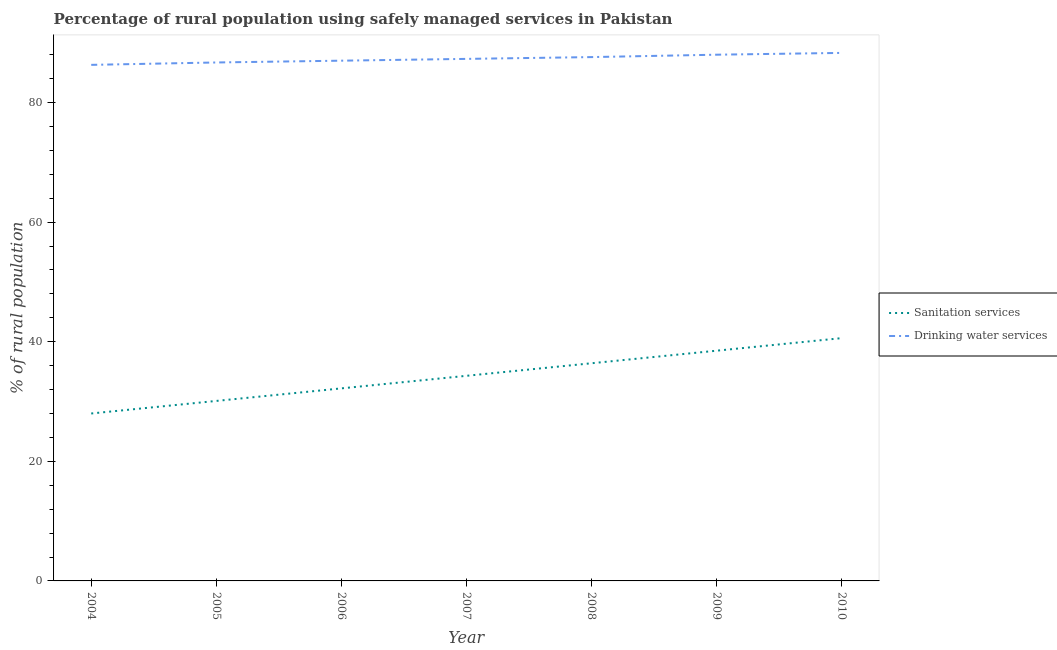Does the line corresponding to percentage of rural population who used sanitation services intersect with the line corresponding to percentage of rural population who used drinking water services?
Keep it short and to the point. No. Is the number of lines equal to the number of legend labels?
Offer a terse response. Yes. What is the percentage of rural population who used sanitation services in 2007?
Provide a succinct answer. 34.3. Across all years, what is the maximum percentage of rural population who used drinking water services?
Offer a terse response. 88.3. Across all years, what is the minimum percentage of rural population who used sanitation services?
Your answer should be compact. 28. In which year was the percentage of rural population who used sanitation services minimum?
Offer a terse response. 2004. What is the total percentage of rural population who used drinking water services in the graph?
Make the answer very short. 611.2. What is the difference between the percentage of rural population who used sanitation services in 2004 and that in 2007?
Provide a short and direct response. -6.3. What is the difference between the percentage of rural population who used drinking water services in 2010 and the percentage of rural population who used sanitation services in 2009?
Offer a very short reply. 49.8. What is the average percentage of rural population who used drinking water services per year?
Ensure brevity in your answer.  87.31. In the year 2009, what is the difference between the percentage of rural population who used sanitation services and percentage of rural population who used drinking water services?
Your answer should be very brief. -49.5. What is the ratio of the percentage of rural population who used drinking water services in 2005 to that in 2009?
Offer a terse response. 0.99. Is the percentage of rural population who used sanitation services in 2006 less than that in 2009?
Make the answer very short. Yes. Is the difference between the percentage of rural population who used drinking water services in 2007 and 2008 greater than the difference between the percentage of rural population who used sanitation services in 2007 and 2008?
Offer a very short reply. Yes. What is the difference between the highest and the second highest percentage of rural population who used sanitation services?
Give a very brief answer. 2.1. What is the difference between the highest and the lowest percentage of rural population who used drinking water services?
Give a very brief answer. 2. In how many years, is the percentage of rural population who used drinking water services greater than the average percentage of rural population who used drinking water services taken over all years?
Ensure brevity in your answer.  3. Is the sum of the percentage of rural population who used sanitation services in 2005 and 2010 greater than the maximum percentage of rural population who used drinking water services across all years?
Ensure brevity in your answer.  No. Does the percentage of rural population who used sanitation services monotonically increase over the years?
Give a very brief answer. Yes. Is the percentage of rural population who used drinking water services strictly greater than the percentage of rural population who used sanitation services over the years?
Your answer should be compact. Yes. How many lines are there?
Your answer should be very brief. 2. How many years are there in the graph?
Your answer should be very brief. 7. Are the values on the major ticks of Y-axis written in scientific E-notation?
Your response must be concise. No. Does the graph contain any zero values?
Provide a succinct answer. No. How many legend labels are there?
Provide a succinct answer. 2. What is the title of the graph?
Provide a short and direct response. Percentage of rural population using safely managed services in Pakistan. Does "DAC donors" appear as one of the legend labels in the graph?
Keep it short and to the point. No. What is the label or title of the X-axis?
Provide a short and direct response. Year. What is the label or title of the Y-axis?
Your answer should be compact. % of rural population. What is the % of rural population in Sanitation services in 2004?
Offer a terse response. 28. What is the % of rural population of Drinking water services in 2004?
Offer a very short reply. 86.3. What is the % of rural population of Sanitation services in 2005?
Your answer should be very brief. 30.1. What is the % of rural population in Drinking water services in 2005?
Give a very brief answer. 86.7. What is the % of rural population of Sanitation services in 2006?
Your response must be concise. 32.2. What is the % of rural population of Sanitation services in 2007?
Your response must be concise. 34.3. What is the % of rural population in Drinking water services in 2007?
Ensure brevity in your answer.  87.3. What is the % of rural population of Sanitation services in 2008?
Your answer should be compact. 36.4. What is the % of rural population in Drinking water services in 2008?
Your response must be concise. 87.6. What is the % of rural population in Sanitation services in 2009?
Make the answer very short. 38.5. What is the % of rural population of Drinking water services in 2009?
Your answer should be very brief. 88. What is the % of rural population of Sanitation services in 2010?
Ensure brevity in your answer.  40.6. What is the % of rural population in Drinking water services in 2010?
Ensure brevity in your answer.  88.3. Across all years, what is the maximum % of rural population in Sanitation services?
Make the answer very short. 40.6. Across all years, what is the maximum % of rural population of Drinking water services?
Your answer should be compact. 88.3. Across all years, what is the minimum % of rural population in Drinking water services?
Give a very brief answer. 86.3. What is the total % of rural population of Sanitation services in the graph?
Your answer should be compact. 240.1. What is the total % of rural population in Drinking water services in the graph?
Provide a succinct answer. 611.2. What is the difference between the % of rural population of Drinking water services in 2004 and that in 2005?
Provide a short and direct response. -0.4. What is the difference between the % of rural population of Sanitation services in 2004 and that in 2006?
Make the answer very short. -4.2. What is the difference between the % of rural population of Drinking water services in 2004 and that in 2009?
Make the answer very short. -1.7. What is the difference between the % of rural population of Sanitation services in 2004 and that in 2010?
Keep it short and to the point. -12.6. What is the difference between the % of rural population in Sanitation services in 2005 and that in 2006?
Your answer should be compact. -2.1. What is the difference between the % of rural population in Drinking water services in 2005 and that in 2007?
Keep it short and to the point. -0.6. What is the difference between the % of rural population in Sanitation services in 2005 and that in 2008?
Give a very brief answer. -6.3. What is the difference between the % of rural population of Drinking water services in 2005 and that in 2008?
Provide a short and direct response. -0.9. What is the difference between the % of rural population in Drinking water services in 2005 and that in 2009?
Keep it short and to the point. -1.3. What is the difference between the % of rural population in Sanitation services in 2005 and that in 2010?
Offer a terse response. -10.5. What is the difference between the % of rural population in Drinking water services in 2005 and that in 2010?
Provide a succinct answer. -1.6. What is the difference between the % of rural population in Sanitation services in 2006 and that in 2007?
Make the answer very short. -2.1. What is the difference between the % of rural population in Sanitation services in 2006 and that in 2008?
Give a very brief answer. -4.2. What is the difference between the % of rural population in Drinking water services in 2006 and that in 2008?
Your answer should be compact. -0.6. What is the difference between the % of rural population in Sanitation services in 2006 and that in 2009?
Ensure brevity in your answer.  -6.3. What is the difference between the % of rural population in Sanitation services in 2007 and that in 2008?
Your answer should be compact. -2.1. What is the difference between the % of rural population in Sanitation services in 2007 and that in 2009?
Your answer should be compact. -4.2. What is the difference between the % of rural population in Sanitation services in 2007 and that in 2010?
Ensure brevity in your answer.  -6.3. What is the difference between the % of rural population in Sanitation services in 2008 and that in 2009?
Provide a short and direct response. -2.1. What is the difference between the % of rural population in Drinking water services in 2008 and that in 2009?
Your answer should be very brief. -0.4. What is the difference between the % of rural population in Sanitation services in 2008 and that in 2010?
Keep it short and to the point. -4.2. What is the difference between the % of rural population of Sanitation services in 2009 and that in 2010?
Your response must be concise. -2.1. What is the difference between the % of rural population of Drinking water services in 2009 and that in 2010?
Give a very brief answer. -0.3. What is the difference between the % of rural population in Sanitation services in 2004 and the % of rural population in Drinking water services in 2005?
Keep it short and to the point. -58.7. What is the difference between the % of rural population of Sanitation services in 2004 and the % of rural population of Drinking water services in 2006?
Provide a short and direct response. -59. What is the difference between the % of rural population in Sanitation services in 2004 and the % of rural population in Drinking water services in 2007?
Offer a terse response. -59.3. What is the difference between the % of rural population in Sanitation services in 2004 and the % of rural population in Drinking water services in 2008?
Offer a terse response. -59.6. What is the difference between the % of rural population in Sanitation services in 2004 and the % of rural population in Drinking water services in 2009?
Make the answer very short. -60. What is the difference between the % of rural population of Sanitation services in 2004 and the % of rural population of Drinking water services in 2010?
Your response must be concise. -60.3. What is the difference between the % of rural population in Sanitation services in 2005 and the % of rural population in Drinking water services in 2006?
Keep it short and to the point. -56.9. What is the difference between the % of rural population of Sanitation services in 2005 and the % of rural population of Drinking water services in 2007?
Offer a very short reply. -57.2. What is the difference between the % of rural population of Sanitation services in 2005 and the % of rural population of Drinking water services in 2008?
Give a very brief answer. -57.5. What is the difference between the % of rural population in Sanitation services in 2005 and the % of rural population in Drinking water services in 2009?
Your response must be concise. -57.9. What is the difference between the % of rural population in Sanitation services in 2005 and the % of rural population in Drinking water services in 2010?
Ensure brevity in your answer.  -58.2. What is the difference between the % of rural population in Sanitation services in 2006 and the % of rural population in Drinking water services in 2007?
Make the answer very short. -55.1. What is the difference between the % of rural population in Sanitation services in 2006 and the % of rural population in Drinking water services in 2008?
Offer a very short reply. -55.4. What is the difference between the % of rural population in Sanitation services in 2006 and the % of rural population in Drinking water services in 2009?
Your answer should be very brief. -55.8. What is the difference between the % of rural population in Sanitation services in 2006 and the % of rural population in Drinking water services in 2010?
Offer a very short reply. -56.1. What is the difference between the % of rural population of Sanitation services in 2007 and the % of rural population of Drinking water services in 2008?
Offer a terse response. -53.3. What is the difference between the % of rural population of Sanitation services in 2007 and the % of rural population of Drinking water services in 2009?
Ensure brevity in your answer.  -53.7. What is the difference between the % of rural population in Sanitation services in 2007 and the % of rural population in Drinking water services in 2010?
Offer a very short reply. -54. What is the difference between the % of rural population in Sanitation services in 2008 and the % of rural population in Drinking water services in 2009?
Make the answer very short. -51.6. What is the difference between the % of rural population in Sanitation services in 2008 and the % of rural population in Drinking water services in 2010?
Keep it short and to the point. -51.9. What is the difference between the % of rural population in Sanitation services in 2009 and the % of rural population in Drinking water services in 2010?
Your response must be concise. -49.8. What is the average % of rural population in Sanitation services per year?
Your response must be concise. 34.3. What is the average % of rural population of Drinking water services per year?
Your answer should be compact. 87.31. In the year 2004, what is the difference between the % of rural population in Sanitation services and % of rural population in Drinking water services?
Provide a succinct answer. -58.3. In the year 2005, what is the difference between the % of rural population of Sanitation services and % of rural population of Drinking water services?
Offer a very short reply. -56.6. In the year 2006, what is the difference between the % of rural population of Sanitation services and % of rural population of Drinking water services?
Make the answer very short. -54.8. In the year 2007, what is the difference between the % of rural population of Sanitation services and % of rural population of Drinking water services?
Provide a short and direct response. -53. In the year 2008, what is the difference between the % of rural population of Sanitation services and % of rural population of Drinking water services?
Ensure brevity in your answer.  -51.2. In the year 2009, what is the difference between the % of rural population in Sanitation services and % of rural population in Drinking water services?
Give a very brief answer. -49.5. In the year 2010, what is the difference between the % of rural population in Sanitation services and % of rural population in Drinking water services?
Make the answer very short. -47.7. What is the ratio of the % of rural population in Sanitation services in 2004 to that in 2005?
Your answer should be very brief. 0.93. What is the ratio of the % of rural population of Drinking water services in 2004 to that in 2005?
Offer a very short reply. 1. What is the ratio of the % of rural population in Sanitation services in 2004 to that in 2006?
Ensure brevity in your answer.  0.87. What is the ratio of the % of rural population of Drinking water services in 2004 to that in 2006?
Your answer should be very brief. 0.99. What is the ratio of the % of rural population of Sanitation services in 2004 to that in 2007?
Ensure brevity in your answer.  0.82. What is the ratio of the % of rural population of Drinking water services in 2004 to that in 2007?
Keep it short and to the point. 0.99. What is the ratio of the % of rural population of Sanitation services in 2004 to that in 2008?
Make the answer very short. 0.77. What is the ratio of the % of rural population in Drinking water services in 2004 to that in 2008?
Ensure brevity in your answer.  0.99. What is the ratio of the % of rural population of Sanitation services in 2004 to that in 2009?
Ensure brevity in your answer.  0.73. What is the ratio of the % of rural population of Drinking water services in 2004 to that in 2009?
Offer a terse response. 0.98. What is the ratio of the % of rural population of Sanitation services in 2004 to that in 2010?
Offer a very short reply. 0.69. What is the ratio of the % of rural population of Drinking water services in 2004 to that in 2010?
Make the answer very short. 0.98. What is the ratio of the % of rural population of Sanitation services in 2005 to that in 2006?
Give a very brief answer. 0.93. What is the ratio of the % of rural population in Drinking water services in 2005 to that in 2006?
Offer a terse response. 1. What is the ratio of the % of rural population in Sanitation services in 2005 to that in 2007?
Keep it short and to the point. 0.88. What is the ratio of the % of rural population in Drinking water services in 2005 to that in 2007?
Your response must be concise. 0.99. What is the ratio of the % of rural population of Sanitation services in 2005 to that in 2008?
Offer a very short reply. 0.83. What is the ratio of the % of rural population of Drinking water services in 2005 to that in 2008?
Your response must be concise. 0.99. What is the ratio of the % of rural population in Sanitation services in 2005 to that in 2009?
Your answer should be very brief. 0.78. What is the ratio of the % of rural population of Drinking water services in 2005 to that in 2009?
Your answer should be compact. 0.99. What is the ratio of the % of rural population in Sanitation services in 2005 to that in 2010?
Your response must be concise. 0.74. What is the ratio of the % of rural population in Drinking water services in 2005 to that in 2010?
Provide a succinct answer. 0.98. What is the ratio of the % of rural population in Sanitation services in 2006 to that in 2007?
Provide a succinct answer. 0.94. What is the ratio of the % of rural population in Sanitation services in 2006 to that in 2008?
Make the answer very short. 0.88. What is the ratio of the % of rural population of Drinking water services in 2006 to that in 2008?
Make the answer very short. 0.99. What is the ratio of the % of rural population of Sanitation services in 2006 to that in 2009?
Your answer should be compact. 0.84. What is the ratio of the % of rural population of Drinking water services in 2006 to that in 2009?
Give a very brief answer. 0.99. What is the ratio of the % of rural population of Sanitation services in 2006 to that in 2010?
Your answer should be compact. 0.79. What is the ratio of the % of rural population in Sanitation services in 2007 to that in 2008?
Make the answer very short. 0.94. What is the ratio of the % of rural population of Sanitation services in 2007 to that in 2009?
Provide a succinct answer. 0.89. What is the ratio of the % of rural population in Sanitation services in 2007 to that in 2010?
Offer a very short reply. 0.84. What is the ratio of the % of rural population in Drinking water services in 2007 to that in 2010?
Your response must be concise. 0.99. What is the ratio of the % of rural population of Sanitation services in 2008 to that in 2009?
Your answer should be compact. 0.95. What is the ratio of the % of rural population of Drinking water services in 2008 to that in 2009?
Your answer should be very brief. 1. What is the ratio of the % of rural population in Sanitation services in 2008 to that in 2010?
Make the answer very short. 0.9. What is the ratio of the % of rural population of Drinking water services in 2008 to that in 2010?
Your answer should be very brief. 0.99. What is the ratio of the % of rural population of Sanitation services in 2009 to that in 2010?
Give a very brief answer. 0.95. What is the ratio of the % of rural population in Drinking water services in 2009 to that in 2010?
Provide a succinct answer. 1. What is the difference between the highest and the second highest % of rural population of Sanitation services?
Your response must be concise. 2.1. What is the difference between the highest and the second highest % of rural population in Drinking water services?
Give a very brief answer. 0.3. 